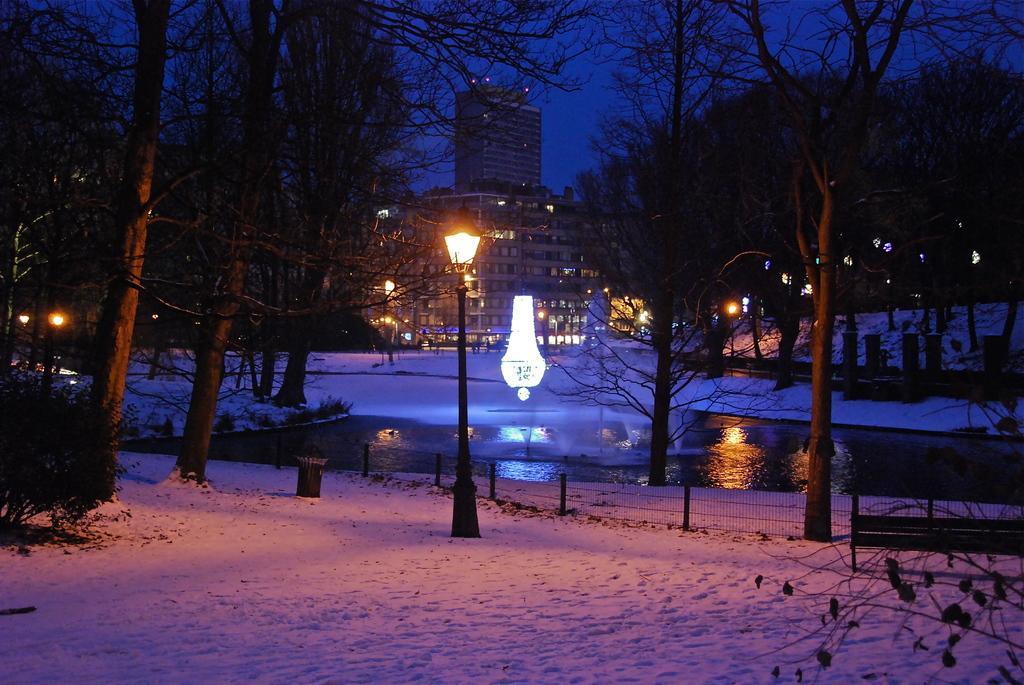How would you summarize this image in a sentence or two? In this image I can see some snow on the ground, few black colored poles and lights on them, a chandelier, few trees, a bench on the right side of the image, the water, few lights and few buildings. In the background I can see the sky. 